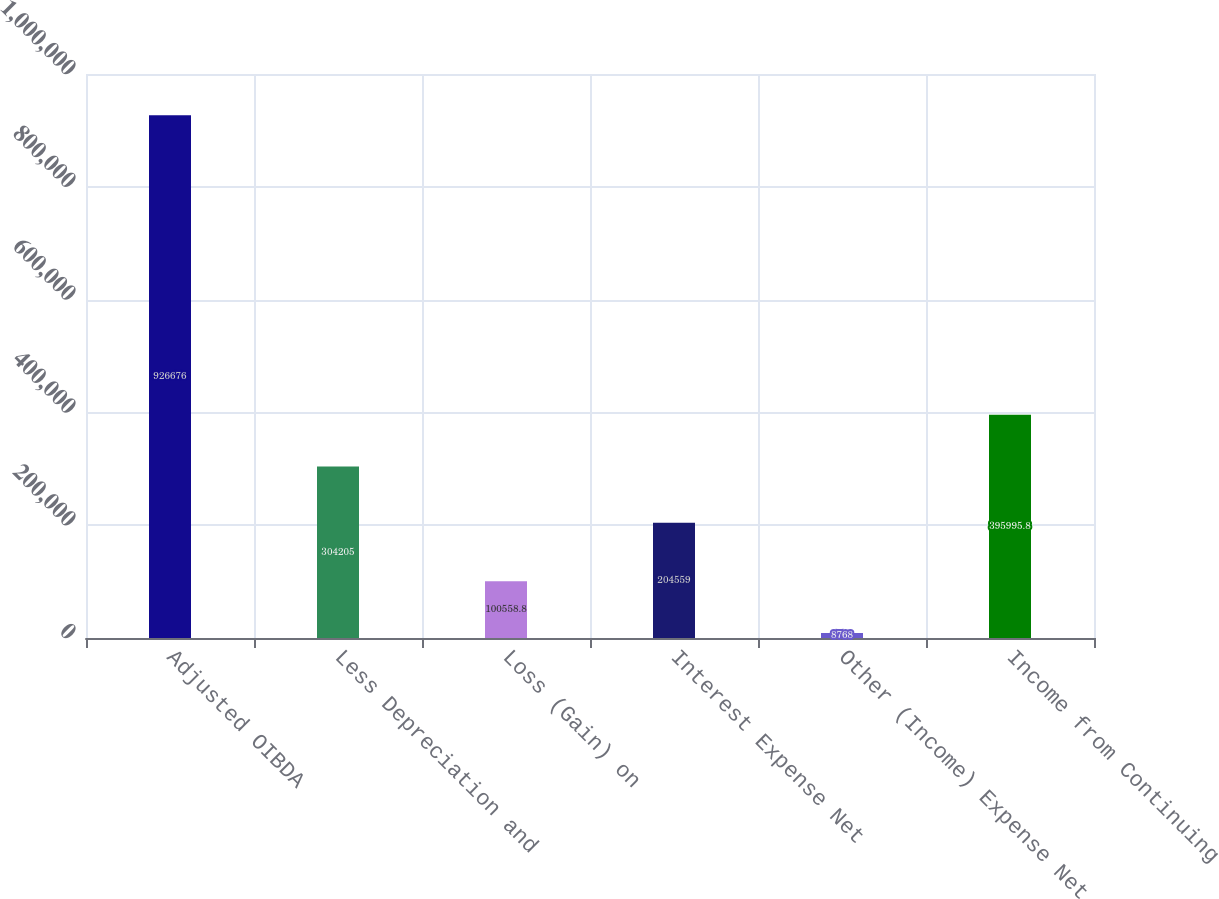Convert chart to OTSL. <chart><loc_0><loc_0><loc_500><loc_500><bar_chart><fcel>Adjusted OIBDA<fcel>Less Depreciation and<fcel>Loss (Gain) on<fcel>Interest Expense Net<fcel>Other (Income) Expense Net<fcel>Income from Continuing<nl><fcel>926676<fcel>304205<fcel>100559<fcel>204559<fcel>8768<fcel>395996<nl></chart> 